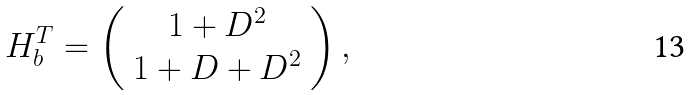Convert formula to latex. <formula><loc_0><loc_0><loc_500><loc_500>H _ { b } ^ { T } = \left ( \begin{array} { c } 1 + D ^ { 2 } \\ 1 + D + D ^ { 2 } \end{array} \right ) ,</formula> 